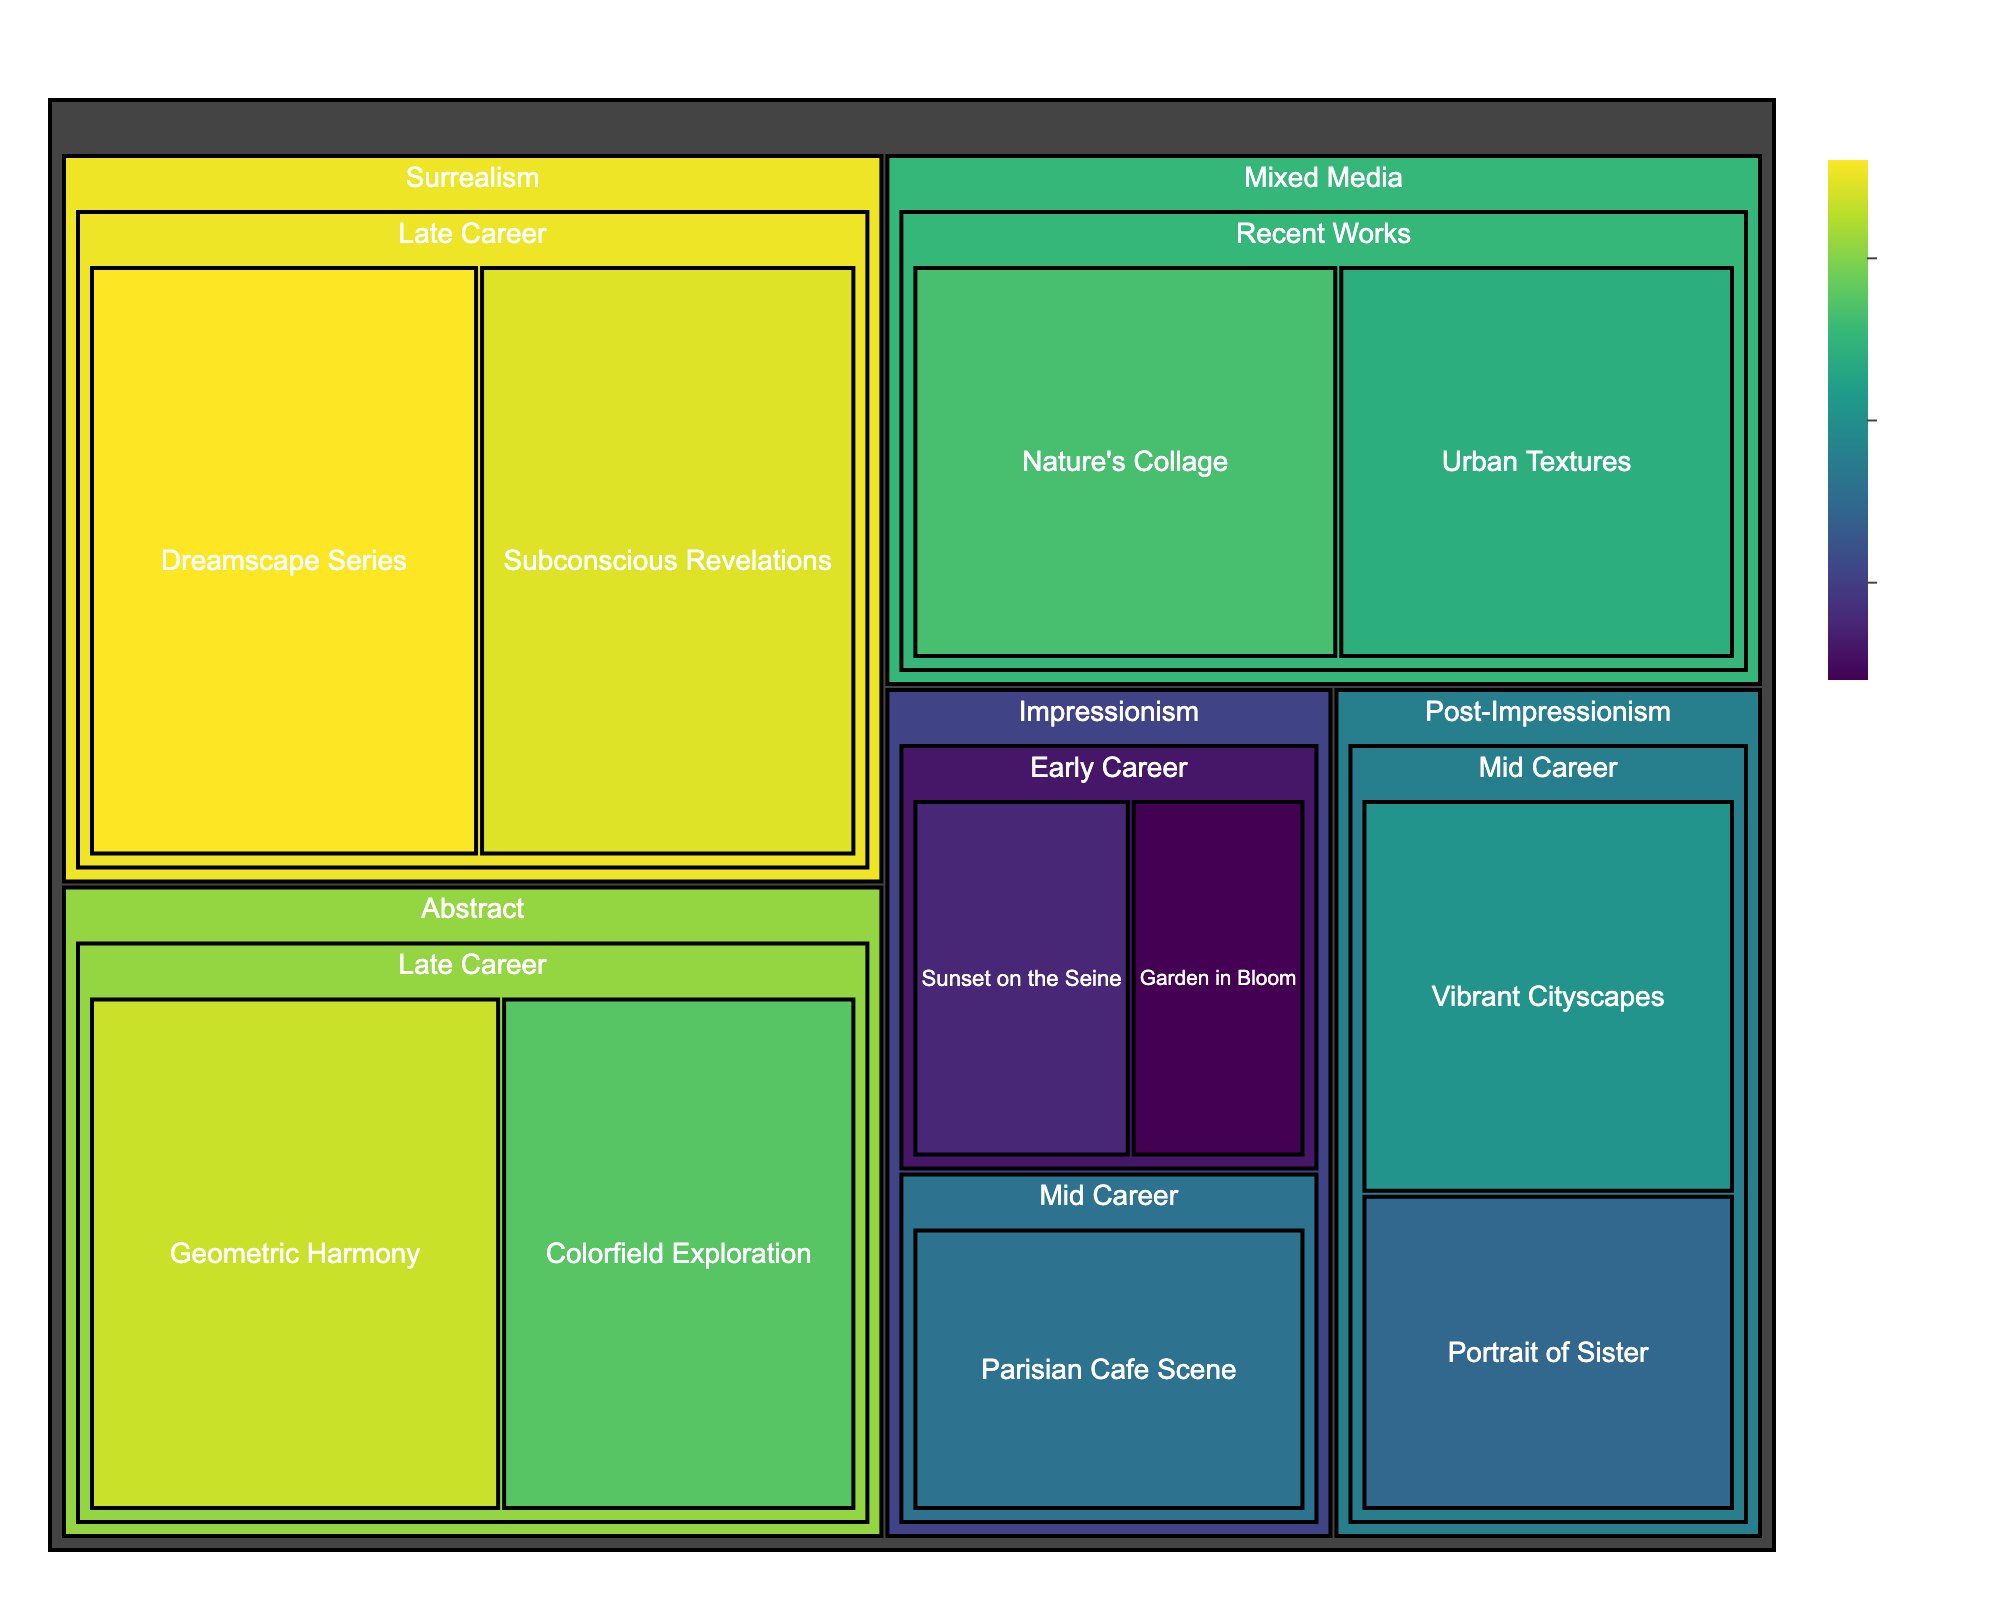What's the title of the figure? The title is usually displayed at the top of the treemap. Simply look for the text on top.
Answer: "Artist's Portfolio Composition" Which artistic style has the highest cumulative value? Sum the values of all artworks within each artistic style and compare the totals. Surrealism has values of 9200 and 8900, totaling to 18100 which is the highest among all styles.
Answer: Surrealism What is the total value of Impressionism artworks? Add the values of Impressionism artworks: 3500 (Sunset on the Seine) + 2800 (Garden in Bloom) + 5200 (Parisian Cafe Scene).
Answer: 11500 Which artwork in the Late Career period has the highest value? Compare the values of all artworks listed under the Late Career period. Dreamscape Series in Surrealism has the highest value of 9200.
Answer: Dreamscape Series How does the value of "Geometric Harmony" compare to "Urban Textures"? Compare the respective values of the artworks. "Geometric Harmony" is valued at 8700 and "Urban Textures" at 6800. 8700 is greater than 6800.
Answer: Geometric Harmony is higher What is the average value of artworks in the Mid Career period? Add the values of Mid Career artworks and divide by the number of artworks: (5200 + 6100 + 4900) / 3 = 16200 / 3.
Answer: 5400 Which period has the lowest cumulative value of artworks? Sum the artwork values for each period and compare totals. Early Career: 6300, Mid Career: 16200, Late Career: 34300, Recent Works: 14100. Early Career has the lowest total.
Answer: Early Career Is the value of "Portrait of Sister" higher or lower than "Colorfield Exploration"? Compare the values: "Portrait of Sister" (4900) vs. "Colorfield Exploration" (7500).
Answer: Lower What percentage of the total portfolio value does "Nature's Collage" represent? Calculate the total portfolio value by summing all artwork values. Then, (7300 / total value) * 100. Total value = 11500 + 16200 + 34300 + 14100 = 76100; (7300 / 76100) * 100.
Answer: Approximately 9.59% Which artistic style has more value, Abstract or Mixed Media? Sum the values within each style and compare. Abstract: 8700 + 7500 = 16200, Mixed Media: 6800 + 7300 = 14100. Abstract has a higher total value.
Answer: Abstract 